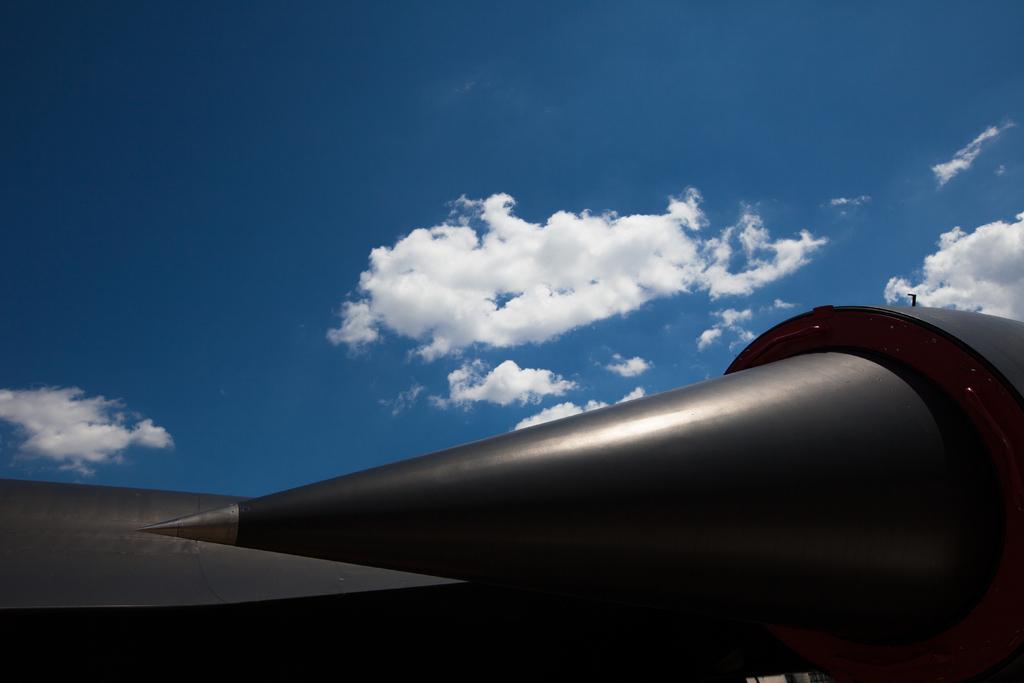Could you give a brief overview of what you see in this image? At the bottom of the image there is a black color object. At the top of the image there is sky and clouds. 